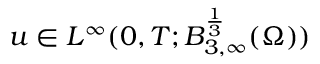<formula> <loc_0><loc_0><loc_500><loc_500>u \in L ^ { \infty } ( 0 , T ; B _ { 3 , \infty } ^ { \frac { 1 } { 3 } } ( \Omega ) )</formula> 